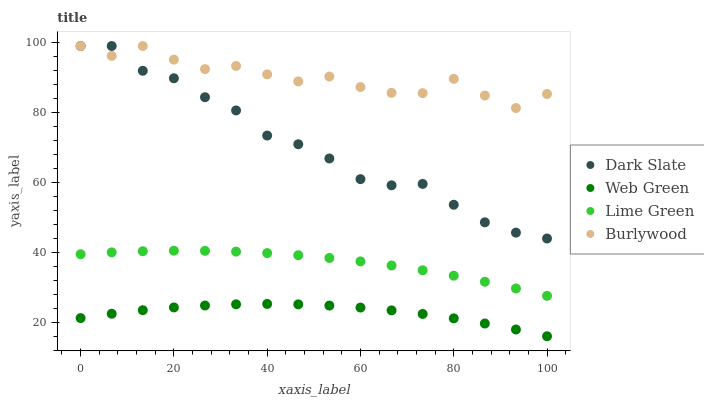Does Web Green have the minimum area under the curve?
Answer yes or no. Yes. Does Burlywood have the maximum area under the curve?
Answer yes or no. Yes. Does Dark Slate have the minimum area under the curve?
Answer yes or no. No. Does Dark Slate have the maximum area under the curve?
Answer yes or no. No. Is Lime Green the smoothest?
Answer yes or no. Yes. Is Burlywood the roughest?
Answer yes or no. Yes. Is Dark Slate the smoothest?
Answer yes or no. No. Is Dark Slate the roughest?
Answer yes or no. No. Does Web Green have the lowest value?
Answer yes or no. Yes. Does Dark Slate have the lowest value?
Answer yes or no. No. Does Dark Slate have the highest value?
Answer yes or no. Yes. Does Lime Green have the highest value?
Answer yes or no. No. Is Lime Green less than Dark Slate?
Answer yes or no. Yes. Is Dark Slate greater than Web Green?
Answer yes or no. Yes. Does Burlywood intersect Dark Slate?
Answer yes or no. Yes. Is Burlywood less than Dark Slate?
Answer yes or no. No. Is Burlywood greater than Dark Slate?
Answer yes or no. No. Does Lime Green intersect Dark Slate?
Answer yes or no. No. 